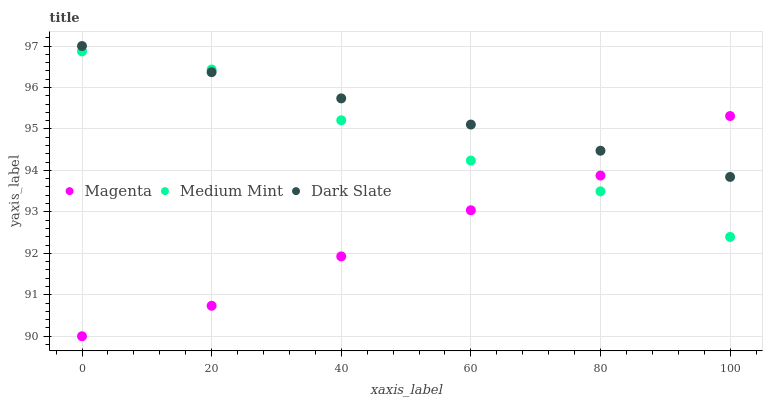Does Magenta have the minimum area under the curve?
Answer yes or no. Yes. Does Dark Slate have the maximum area under the curve?
Answer yes or no. Yes. Does Dark Slate have the minimum area under the curve?
Answer yes or no. No. Does Magenta have the maximum area under the curve?
Answer yes or no. No. Is Dark Slate the smoothest?
Answer yes or no. Yes. Is Medium Mint the roughest?
Answer yes or no. Yes. Is Magenta the smoothest?
Answer yes or no. No. Is Magenta the roughest?
Answer yes or no. No. Does Magenta have the lowest value?
Answer yes or no. Yes. Does Dark Slate have the lowest value?
Answer yes or no. No. Does Dark Slate have the highest value?
Answer yes or no. Yes. Does Magenta have the highest value?
Answer yes or no. No. Does Dark Slate intersect Medium Mint?
Answer yes or no. Yes. Is Dark Slate less than Medium Mint?
Answer yes or no. No. Is Dark Slate greater than Medium Mint?
Answer yes or no. No. 